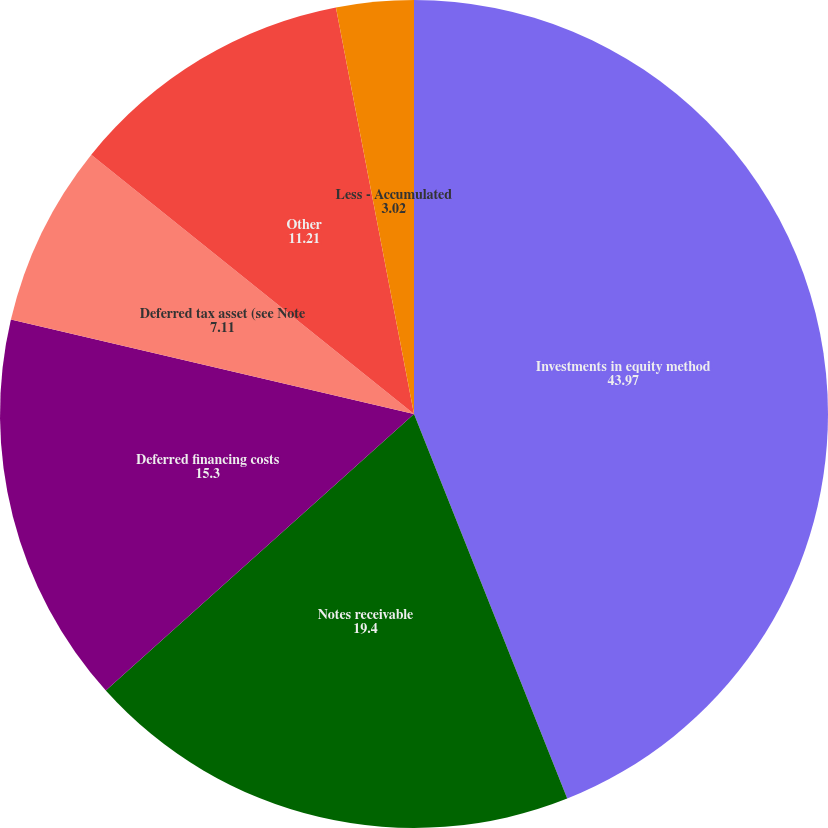Convert chart to OTSL. <chart><loc_0><loc_0><loc_500><loc_500><pie_chart><fcel>Investments in equity method<fcel>Notes receivable<fcel>Deferred financing costs<fcel>Deferred tax asset (see Note<fcel>Other<fcel>Less - Accumulated<nl><fcel>43.97%<fcel>19.4%<fcel>15.3%<fcel>7.11%<fcel>11.21%<fcel>3.02%<nl></chart> 